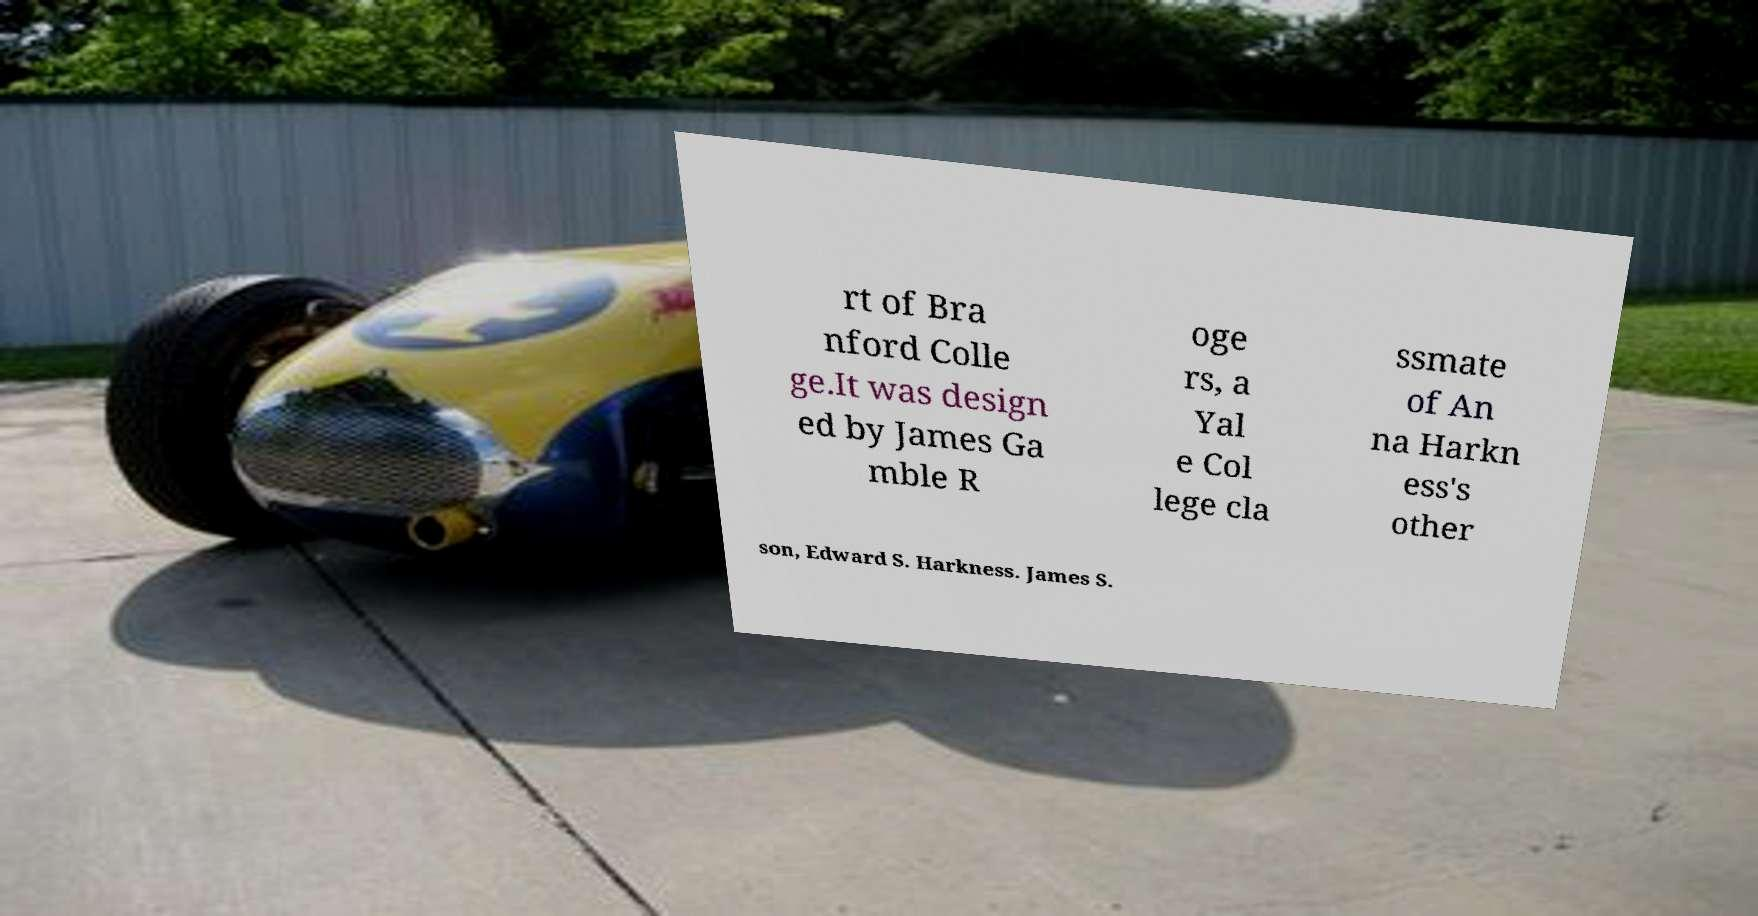Please read and relay the text visible in this image. What does it say? rt of Bra nford Colle ge.It was design ed by James Ga mble R oge rs, a Yal e Col lege cla ssmate of An na Harkn ess's other son, Edward S. Harkness. James S. 